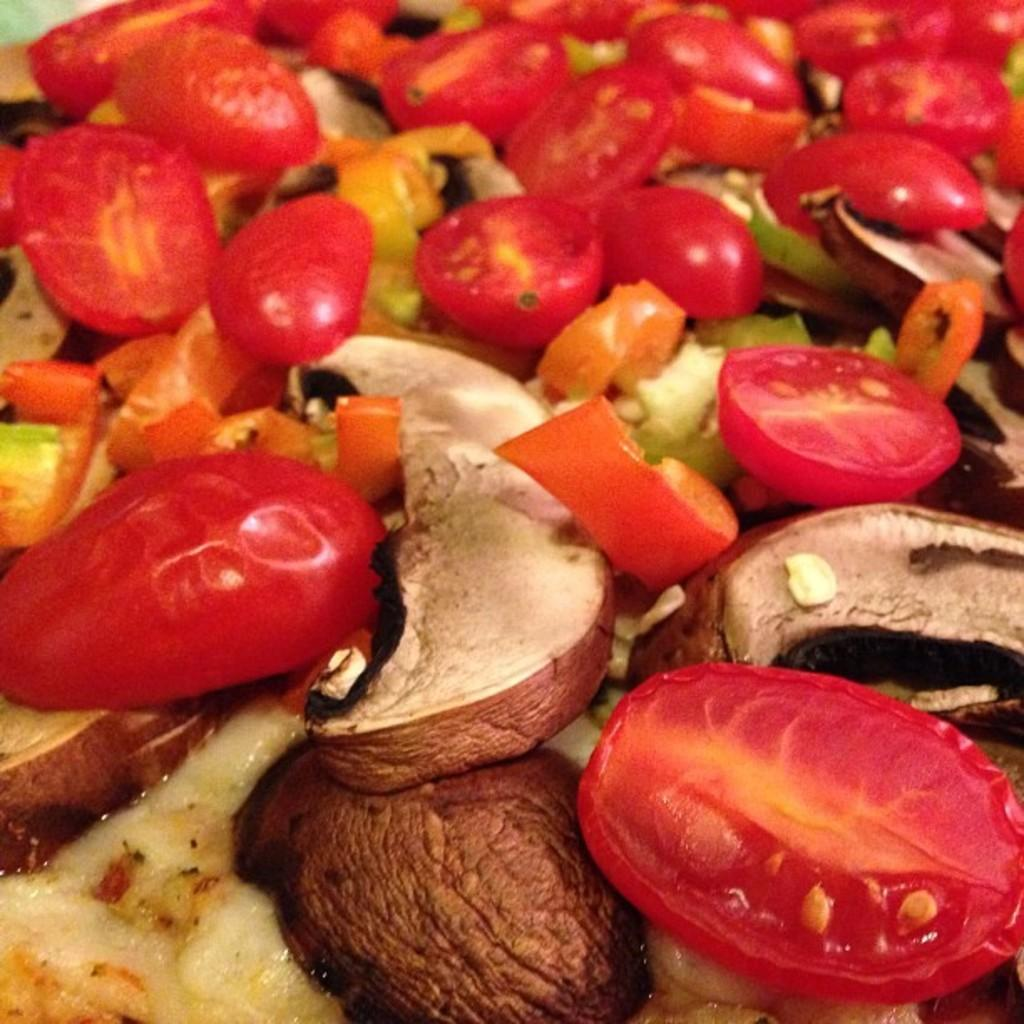What is present in the image? There is food in the image. Can you describe the food in more detail? The food contains tomato slices. What type of marble is used as a backdrop in the image? There is no marble or backdrop present in the image; it only contains food with tomato slices. 